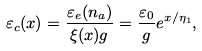Convert formula to latex. <formula><loc_0><loc_0><loc_500><loc_500>\varepsilon _ { c } ( x ) = \frac { \varepsilon _ { e } ( n _ { a } ) } { \xi ( x ) g } = \frac { \varepsilon _ { 0 } } { g } e ^ { x / \eta _ { 1 } } ,</formula> 